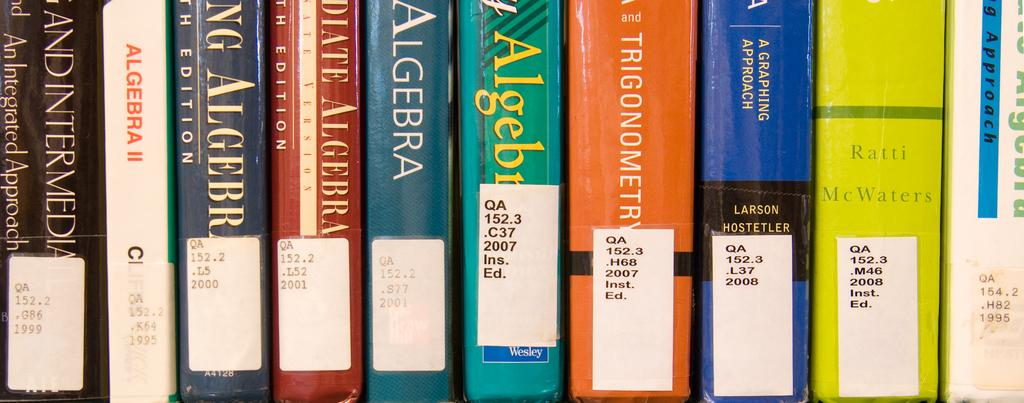<image>
Offer a succinct explanation of the picture presented. a libarary collection of books on Algebra. 